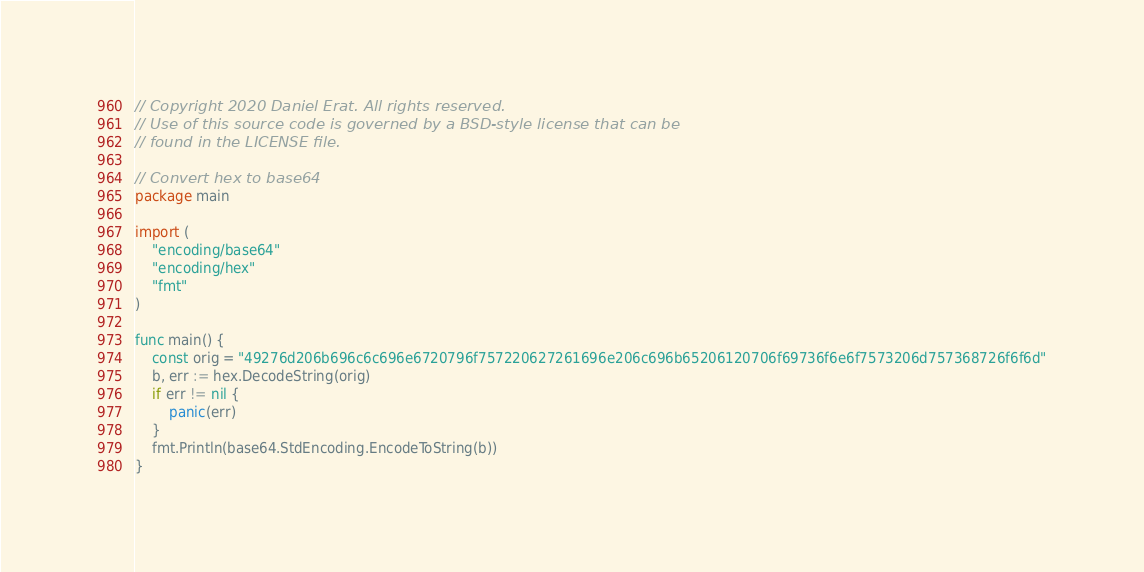<code> <loc_0><loc_0><loc_500><loc_500><_Go_>// Copyright 2020 Daniel Erat. All rights reserved.
// Use of this source code is governed by a BSD-style license that can be
// found in the LICENSE file.

// Convert hex to base64
package main

import (
	"encoding/base64"
	"encoding/hex"
	"fmt"
)

func main() {
	const orig = "49276d206b696c6c696e6720796f757220627261696e206c696b65206120706f69736f6e6f7573206d757368726f6f6d"
	b, err := hex.DecodeString(orig)
	if err != nil {
		panic(err)
	}
	fmt.Println(base64.StdEncoding.EncodeToString(b))
}
</code> 